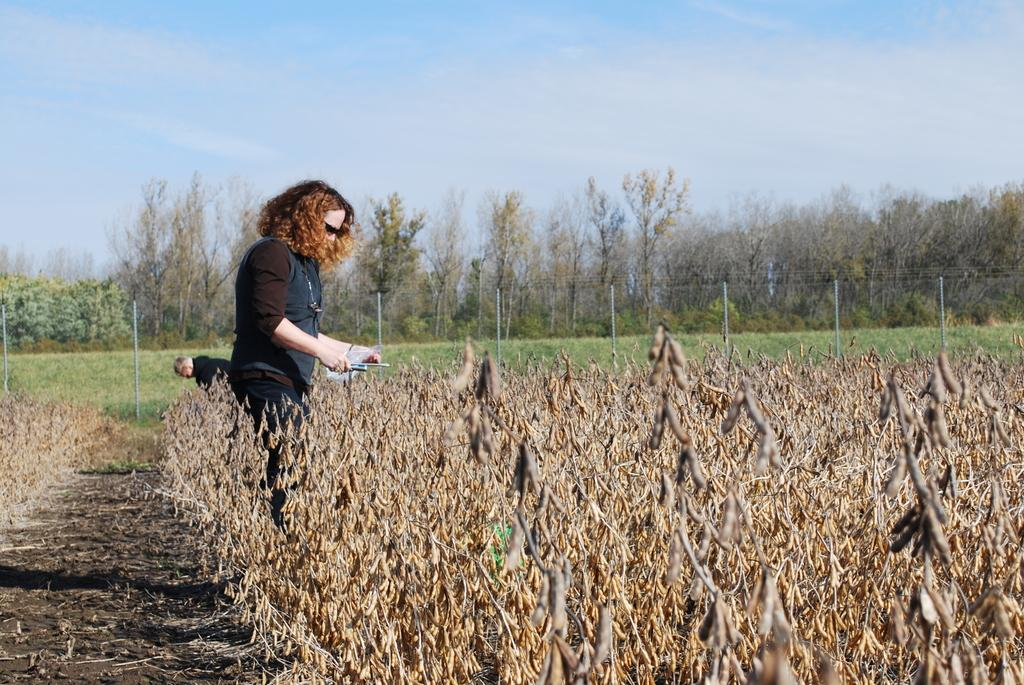What are the people in the image wearing? The people in the image are wearing clothes. What type of ground surface is visible in the image? Soil is visible in the image. What type of vegetation is present in the image? Dry plants and trees are present in the image. What structures can be seen in the image? Poles and a mesh are visible in the image. What part of the natural environment is visible in the image? The sky is visible in the image. What language is being spoken by the people in the image? There is no indication of any language being spoken in the image, as it does not contain any audio or text. What route are the people in the image taking? There is no route visible in the image, as it only shows a static scene with people, plants, and structures. 